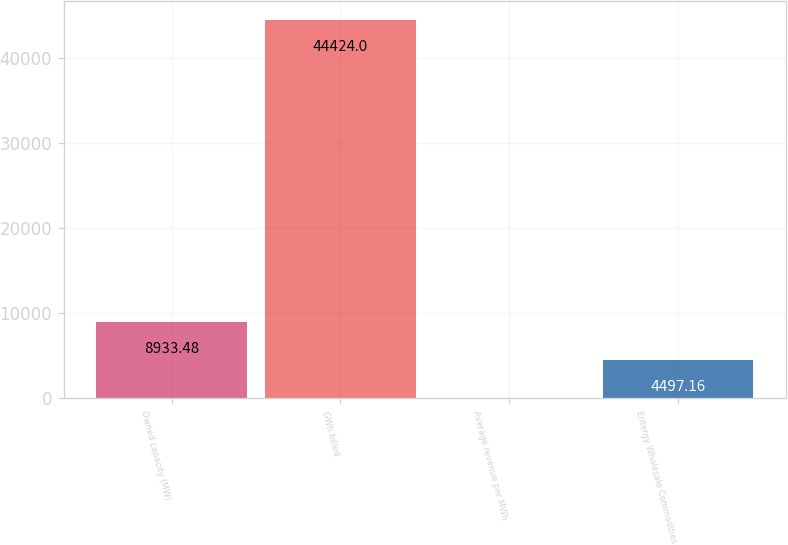Convert chart to OTSL. <chart><loc_0><loc_0><loc_500><loc_500><bar_chart><fcel>Owned capacity (MW)<fcel>GWh billed<fcel>Average revenue per MWh<fcel>Entergy Wholesale Commodities<nl><fcel>8933.48<fcel>44424<fcel>60.84<fcel>4497.16<nl></chart> 